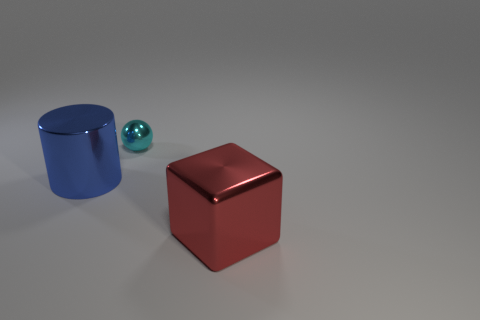Does the cyan thing have the same material as the big blue object?
Give a very brief answer. Yes. How many things are metal things on the right side of the large blue object or big red metal objects?
Offer a terse response. 2. How many other objects are there of the same size as the metallic block?
Offer a very short reply. 1. Are there the same number of big metallic cylinders that are on the right side of the large blue shiny object and large blue shiny things that are in front of the large red shiny cube?
Keep it short and to the point. Yes. Is there anything else that has the same shape as the cyan thing?
Give a very brief answer. No. There is a metallic thing in front of the blue shiny thing; is its color the same as the sphere?
Your answer should be compact. No. What number of other small balls are made of the same material as the ball?
Provide a succinct answer. 0. Are there any cylinders left of the thing that is to the right of the metallic object behind the cylinder?
Offer a terse response. Yes. What shape is the red thing?
Keep it short and to the point. Cube. Is the material of the large object that is behind the metal block the same as the thing that is to the right of the tiny cyan metal object?
Provide a succinct answer. Yes. 